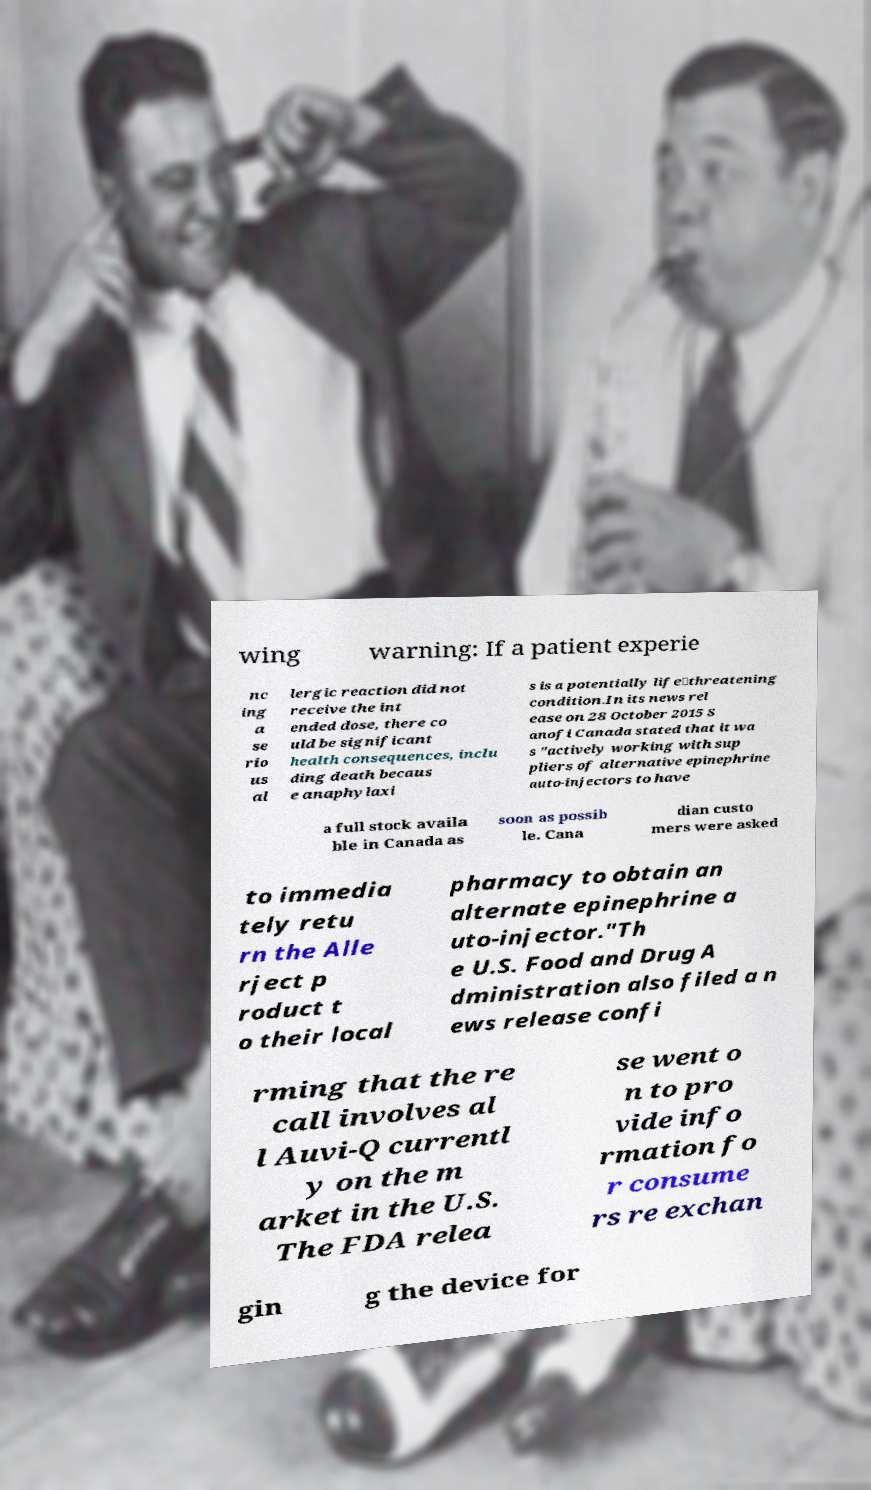Could you extract and type out the text from this image? wing warning: If a patient experie nc ing a se rio us al lergic reaction did not receive the int ended dose, there co uld be significant health consequences, inclu ding death becaus e anaphylaxi s is a potentially life‑threatening condition.In its news rel ease on 28 October 2015 S anofi Canada stated that it wa s "actively working with sup pliers of alternative epinephrine auto-injectors to have a full stock availa ble in Canada as soon as possib le. Cana dian custo mers were asked to immedia tely retu rn the Alle rject p roduct t o their local pharmacy to obtain an alternate epinephrine a uto-injector."Th e U.S. Food and Drug A dministration also filed a n ews release confi rming that the re call involves al l Auvi-Q currentl y on the m arket in the U.S. The FDA relea se went o n to pro vide info rmation fo r consume rs re exchan gin g the device for 